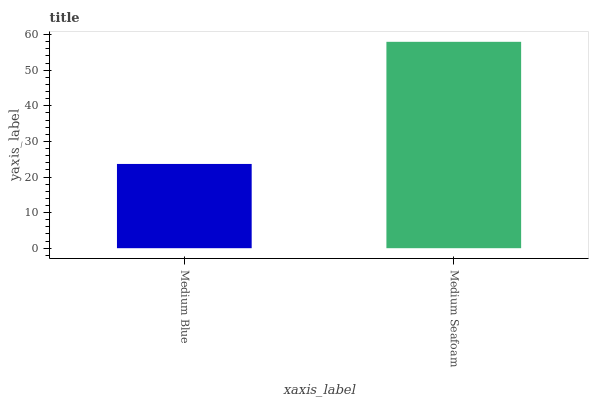Is Medium Seafoam the minimum?
Answer yes or no. No. Is Medium Seafoam greater than Medium Blue?
Answer yes or no. Yes. Is Medium Blue less than Medium Seafoam?
Answer yes or no. Yes. Is Medium Blue greater than Medium Seafoam?
Answer yes or no. No. Is Medium Seafoam less than Medium Blue?
Answer yes or no. No. Is Medium Seafoam the high median?
Answer yes or no. Yes. Is Medium Blue the low median?
Answer yes or no. Yes. Is Medium Blue the high median?
Answer yes or no. No. Is Medium Seafoam the low median?
Answer yes or no. No. 